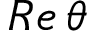<formula> <loc_0><loc_0><loc_500><loc_500>R e \, \theta</formula> 